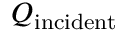<formula> <loc_0><loc_0><loc_500><loc_500>Q _ { i n c i d e n t }</formula> 